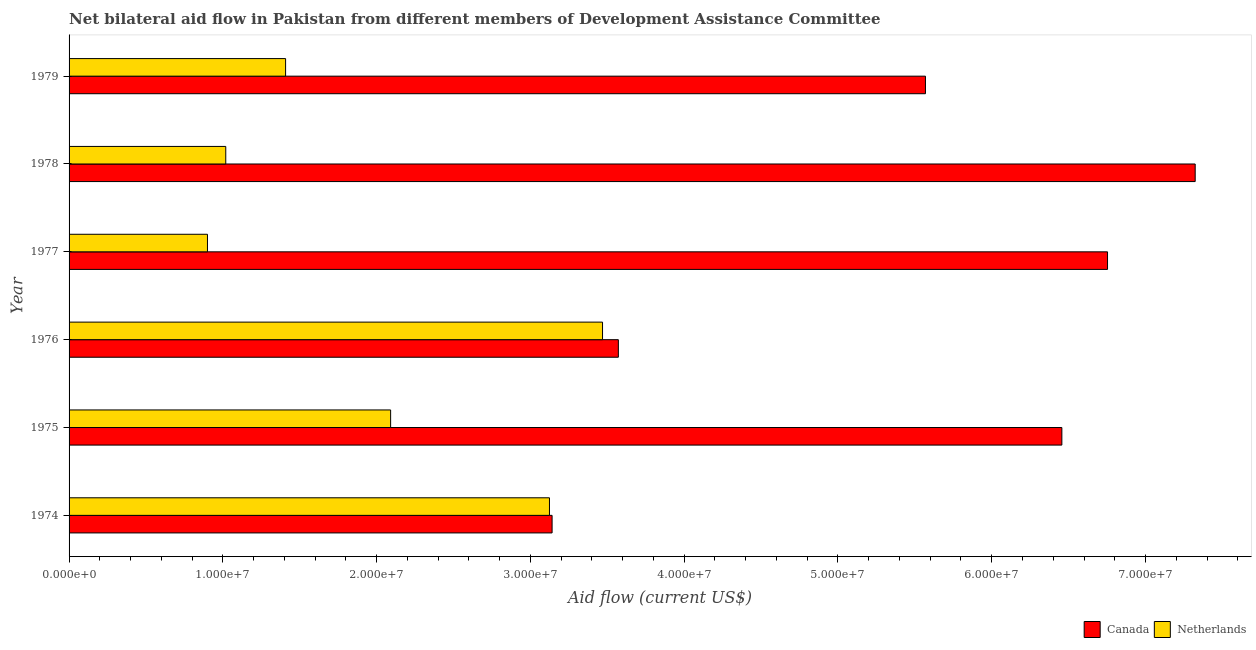How many different coloured bars are there?
Your response must be concise. 2. Are the number of bars on each tick of the Y-axis equal?
Your answer should be compact. Yes. How many bars are there on the 6th tick from the top?
Provide a succinct answer. 2. What is the label of the 2nd group of bars from the top?
Keep it short and to the point. 1978. What is the amount of aid given by netherlands in 1976?
Keep it short and to the point. 3.47e+07. Across all years, what is the maximum amount of aid given by canada?
Your answer should be compact. 7.32e+07. Across all years, what is the minimum amount of aid given by netherlands?
Keep it short and to the point. 9.00e+06. In which year was the amount of aid given by netherlands maximum?
Your response must be concise. 1976. In which year was the amount of aid given by canada minimum?
Ensure brevity in your answer.  1974. What is the total amount of aid given by netherlands in the graph?
Offer a very short reply. 1.20e+08. What is the difference between the amount of aid given by canada in 1975 and that in 1978?
Give a very brief answer. -8.67e+06. What is the difference between the amount of aid given by canada in 1975 and the amount of aid given by netherlands in 1976?
Offer a very short reply. 2.99e+07. What is the average amount of aid given by netherlands per year?
Offer a very short reply. 2.00e+07. In the year 1978, what is the difference between the amount of aid given by canada and amount of aid given by netherlands?
Your answer should be compact. 6.30e+07. What is the ratio of the amount of aid given by canada in 1976 to that in 1978?
Keep it short and to the point. 0.49. What is the difference between the highest and the second highest amount of aid given by netherlands?
Provide a succinct answer. 3.45e+06. What is the difference between the highest and the lowest amount of aid given by netherlands?
Offer a very short reply. 2.57e+07. Is the sum of the amount of aid given by canada in 1976 and 1978 greater than the maximum amount of aid given by netherlands across all years?
Your answer should be compact. Yes. What does the 1st bar from the bottom in 1977 represents?
Provide a succinct answer. Canada. How many years are there in the graph?
Offer a very short reply. 6. What is the difference between two consecutive major ticks on the X-axis?
Ensure brevity in your answer.  1.00e+07. Does the graph contain any zero values?
Your answer should be compact. No. Where does the legend appear in the graph?
Provide a short and direct response. Bottom right. How are the legend labels stacked?
Your answer should be very brief. Horizontal. What is the title of the graph?
Your answer should be very brief. Net bilateral aid flow in Pakistan from different members of Development Assistance Committee. Does "Health Care" appear as one of the legend labels in the graph?
Offer a terse response. No. What is the label or title of the X-axis?
Keep it short and to the point. Aid flow (current US$). What is the Aid flow (current US$) in Canada in 1974?
Provide a succinct answer. 3.14e+07. What is the Aid flow (current US$) of Netherlands in 1974?
Provide a short and direct response. 3.12e+07. What is the Aid flow (current US$) in Canada in 1975?
Ensure brevity in your answer.  6.46e+07. What is the Aid flow (current US$) of Netherlands in 1975?
Keep it short and to the point. 2.09e+07. What is the Aid flow (current US$) in Canada in 1976?
Provide a succinct answer. 3.57e+07. What is the Aid flow (current US$) of Netherlands in 1976?
Provide a short and direct response. 3.47e+07. What is the Aid flow (current US$) of Canada in 1977?
Your answer should be compact. 6.75e+07. What is the Aid flow (current US$) of Netherlands in 1977?
Provide a short and direct response. 9.00e+06. What is the Aid flow (current US$) in Canada in 1978?
Make the answer very short. 7.32e+07. What is the Aid flow (current US$) of Netherlands in 1978?
Make the answer very short. 1.02e+07. What is the Aid flow (current US$) of Canada in 1979?
Provide a short and direct response. 5.57e+07. What is the Aid flow (current US$) of Netherlands in 1979?
Offer a very short reply. 1.41e+07. Across all years, what is the maximum Aid flow (current US$) of Canada?
Offer a very short reply. 7.32e+07. Across all years, what is the maximum Aid flow (current US$) of Netherlands?
Your response must be concise. 3.47e+07. Across all years, what is the minimum Aid flow (current US$) in Canada?
Make the answer very short. 3.14e+07. Across all years, what is the minimum Aid flow (current US$) of Netherlands?
Offer a terse response. 9.00e+06. What is the total Aid flow (current US$) in Canada in the graph?
Keep it short and to the point. 3.28e+08. What is the total Aid flow (current US$) in Netherlands in the graph?
Offer a very short reply. 1.20e+08. What is the difference between the Aid flow (current US$) in Canada in 1974 and that in 1975?
Offer a very short reply. -3.32e+07. What is the difference between the Aid flow (current US$) in Netherlands in 1974 and that in 1975?
Provide a short and direct response. 1.03e+07. What is the difference between the Aid flow (current US$) in Canada in 1974 and that in 1976?
Keep it short and to the point. -4.31e+06. What is the difference between the Aid flow (current US$) in Netherlands in 1974 and that in 1976?
Provide a short and direct response. -3.45e+06. What is the difference between the Aid flow (current US$) of Canada in 1974 and that in 1977?
Provide a short and direct response. -3.61e+07. What is the difference between the Aid flow (current US$) of Netherlands in 1974 and that in 1977?
Offer a very short reply. 2.22e+07. What is the difference between the Aid flow (current US$) of Canada in 1974 and that in 1978?
Provide a succinct answer. -4.18e+07. What is the difference between the Aid flow (current US$) in Netherlands in 1974 and that in 1978?
Make the answer very short. 2.10e+07. What is the difference between the Aid flow (current US$) of Canada in 1974 and that in 1979?
Offer a very short reply. -2.43e+07. What is the difference between the Aid flow (current US$) in Netherlands in 1974 and that in 1979?
Ensure brevity in your answer.  1.72e+07. What is the difference between the Aid flow (current US$) of Canada in 1975 and that in 1976?
Ensure brevity in your answer.  2.88e+07. What is the difference between the Aid flow (current US$) in Netherlands in 1975 and that in 1976?
Your answer should be very brief. -1.38e+07. What is the difference between the Aid flow (current US$) of Canada in 1975 and that in 1977?
Offer a terse response. -2.97e+06. What is the difference between the Aid flow (current US$) in Netherlands in 1975 and that in 1977?
Make the answer very short. 1.19e+07. What is the difference between the Aid flow (current US$) in Canada in 1975 and that in 1978?
Give a very brief answer. -8.67e+06. What is the difference between the Aid flow (current US$) of Netherlands in 1975 and that in 1978?
Offer a terse response. 1.07e+07. What is the difference between the Aid flow (current US$) of Canada in 1975 and that in 1979?
Provide a succinct answer. 8.87e+06. What is the difference between the Aid flow (current US$) of Netherlands in 1975 and that in 1979?
Give a very brief answer. 6.83e+06. What is the difference between the Aid flow (current US$) in Canada in 1976 and that in 1977?
Make the answer very short. -3.18e+07. What is the difference between the Aid flow (current US$) of Netherlands in 1976 and that in 1977?
Provide a succinct answer. 2.57e+07. What is the difference between the Aid flow (current US$) in Canada in 1976 and that in 1978?
Make the answer very short. -3.75e+07. What is the difference between the Aid flow (current US$) of Netherlands in 1976 and that in 1978?
Your answer should be very brief. 2.45e+07. What is the difference between the Aid flow (current US$) in Canada in 1976 and that in 1979?
Give a very brief answer. -2.00e+07. What is the difference between the Aid flow (current US$) in Netherlands in 1976 and that in 1979?
Provide a succinct answer. 2.06e+07. What is the difference between the Aid flow (current US$) of Canada in 1977 and that in 1978?
Your response must be concise. -5.70e+06. What is the difference between the Aid flow (current US$) in Netherlands in 1977 and that in 1978?
Make the answer very short. -1.19e+06. What is the difference between the Aid flow (current US$) in Canada in 1977 and that in 1979?
Offer a terse response. 1.18e+07. What is the difference between the Aid flow (current US$) in Netherlands in 1977 and that in 1979?
Provide a succinct answer. -5.08e+06. What is the difference between the Aid flow (current US$) in Canada in 1978 and that in 1979?
Keep it short and to the point. 1.75e+07. What is the difference between the Aid flow (current US$) of Netherlands in 1978 and that in 1979?
Your answer should be compact. -3.89e+06. What is the difference between the Aid flow (current US$) of Canada in 1974 and the Aid flow (current US$) of Netherlands in 1975?
Make the answer very short. 1.05e+07. What is the difference between the Aid flow (current US$) in Canada in 1974 and the Aid flow (current US$) in Netherlands in 1976?
Provide a succinct answer. -3.28e+06. What is the difference between the Aid flow (current US$) of Canada in 1974 and the Aid flow (current US$) of Netherlands in 1977?
Provide a short and direct response. 2.24e+07. What is the difference between the Aid flow (current US$) in Canada in 1974 and the Aid flow (current US$) in Netherlands in 1978?
Your answer should be very brief. 2.12e+07. What is the difference between the Aid flow (current US$) in Canada in 1974 and the Aid flow (current US$) in Netherlands in 1979?
Offer a terse response. 1.73e+07. What is the difference between the Aid flow (current US$) of Canada in 1975 and the Aid flow (current US$) of Netherlands in 1976?
Your response must be concise. 2.99e+07. What is the difference between the Aid flow (current US$) of Canada in 1975 and the Aid flow (current US$) of Netherlands in 1977?
Offer a very short reply. 5.56e+07. What is the difference between the Aid flow (current US$) in Canada in 1975 and the Aid flow (current US$) in Netherlands in 1978?
Provide a succinct answer. 5.44e+07. What is the difference between the Aid flow (current US$) in Canada in 1975 and the Aid flow (current US$) in Netherlands in 1979?
Provide a short and direct response. 5.05e+07. What is the difference between the Aid flow (current US$) of Canada in 1976 and the Aid flow (current US$) of Netherlands in 1977?
Your answer should be very brief. 2.67e+07. What is the difference between the Aid flow (current US$) of Canada in 1976 and the Aid flow (current US$) of Netherlands in 1978?
Provide a succinct answer. 2.55e+07. What is the difference between the Aid flow (current US$) of Canada in 1976 and the Aid flow (current US$) of Netherlands in 1979?
Your answer should be very brief. 2.16e+07. What is the difference between the Aid flow (current US$) in Canada in 1977 and the Aid flow (current US$) in Netherlands in 1978?
Offer a terse response. 5.73e+07. What is the difference between the Aid flow (current US$) of Canada in 1977 and the Aid flow (current US$) of Netherlands in 1979?
Keep it short and to the point. 5.34e+07. What is the difference between the Aid flow (current US$) in Canada in 1978 and the Aid flow (current US$) in Netherlands in 1979?
Offer a terse response. 5.92e+07. What is the average Aid flow (current US$) of Canada per year?
Provide a succinct answer. 5.47e+07. What is the average Aid flow (current US$) in Netherlands per year?
Give a very brief answer. 2.00e+07. In the year 1975, what is the difference between the Aid flow (current US$) in Canada and Aid flow (current US$) in Netherlands?
Offer a very short reply. 4.36e+07. In the year 1976, what is the difference between the Aid flow (current US$) in Canada and Aid flow (current US$) in Netherlands?
Keep it short and to the point. 1.03e+06. In the year 1977, what is the difference between the Aid flow (current US$) in Canada and Aid flow (current US$) in Netherlands?
Your answer should be very brief. 5.85e+07. In the year 1978, what is the difference between the Aid flow (current US$) in Canada and Aid flow (current US$) in Netherlands?
Offer a terse response. 6.30e+07. In the year 1979, what is the difference between the Aid flow (current US$) of Canada and Aid flow (current US$) of Netherlands?
Ensure brevity in your answer.  4.16e+07. What is the ratio of the Aid flow (current US$) of Canada in 1974 to that in 1975?
Your answer should be very brief. 0.49. What is the ratio of the Aid flow (current US$) of Netherlands in 1974 to that in 1975?
Your response must be concise. 1.49. What is the ratio of the Aid flow (current US$) of Canada in 1974 to that in 1976?
Your answer should be compact. 0.88. What is the ratio of the Aid flow (current US$) of Netherlands in 1974 to that in 1976?
Give a very brief answer. 0.9. What is the ratio of the Aid flow (current US$) of Canada in 1974 to that in 1977?
Offer a terse response. 0.47. What is the ratio of the Aid flow (current US$) in Netherlands in 1974 to that in 1977?
Offer a terse response. 3.47. What is the ratio of the Aid flow (current US$) of Canada in 1974 to that in 1978?
Make the answer very short. 0.43. What is the ratio of the Aid flow (current US$) in Netherlands in 1974 to that in 1978?
Provide a succinct answer. 3.07. What is the ratio of the Aid flow (current US$) in Canada in 1974 to that in 1979?
Give a very brief answer. 0.56. What is the ratio of the Aid flow (current US$) of Netherlands in 1974 to that in 1979?
Provide a succinct answer. 2.22. What is the ratio of the Aid flow (current US$) of Canada in 1975 to that in 1976?
Offer a very short reply. 1.81. What is the ratio of the Aid flow (current US$) of Netherlands in 1975 to that in 1976?
Offer a very short reply. 0.6. What is the ratio of the Aid flow (current US$) of Canada in 1975 to that in 1977?
Give a very brief answer. 0.96. What is the ratio of the Aid flow (current US$) in Netherlands in 1975 to that in 1977?
Make the answer very short. 2.32. What is the ratio of the Aid flow (current US$) of Canada in 1975 to that in 1978?
Offer a terse response. 0.88. What is the ratio of the Aid flow (current US$) of Netherlands in 1975 to that in 1978?
Keep it short and to the point. 2.05. What is the ratio of the Aid flow (current US$) of Canada in 1975 to that in 1979?
Give a very brief answer. 1.16. What is the ratio of the Aid flow (current US$) of Netherlands in 1975 to that in 1979?
Give a very brief answer. 1.49. What is the ratio of the Aid flow (current US$) of Canada in 1976 to that in 1977?
Offer a terse response. 0.53. What is the ratio of the Aid flow (current US$) in Netherlands in 1976 to that in 1977?
Offer a very short reply. 3.85. What is the ratio of the Aid flow (current US$) of Canada in 1976 to that in 1978?
Your response must be concise. 0.49. What is the ratio of the Aid flow (current US$) in Netherlands in 1976 to that in 1978?
Ensure brevity in your answer.  3.4. What is the ratio of the Aid flow (current US$) of Canada in 1976 to that in 1979?
Make the answer very short. 0.64. What is the ratio of the Aid flow (current US$) of Netherlands in 1976 to that in 1979?
Offer a terse response. 2.46. What is the ratio of the Aid flow (current US$) in Canada in 1977 to that in 1978?
Make the answer very short. 0.92. What is the ratio of the Aid flow (current US$) of Netherlands in 1977 to that in 1978?
Ensure brevity in your answer.  0.88. What is the ratio of the Aid flow (current US$) in Canada in 1977 to that in 1979?
Keep it short and to the point. 1.21. What is the ratio of the Aid flow (current US$) in Netherlands in 1977 to that in 1979?
Offer a terse response. 0.64. What is the ratio of the Aid flow (current US$) in Canada in 1978 to that in 1979?
Keep it short and to the point. 1.31. What is the ratio of the Aid flow (current US$) of Netherlands in 1978 to that in 1979?
Provide a short and direct response. 0.72. What is the difference between the highest and the second highest Aid flow (current US$) in Canada?
Your answer should be very brief. 5.70e+06. What is the difference between the highest and the second highest Aid flow (current US$) of Netherlands?
Keep it short and to the point. 3.45e+06. What is the difference between the highest and the lowest Aid flow (current US$) of Canada?
Provide a short and direct response. 4.18e+07. What is the difference between the highest and the lowest Aid flow (current US$) in Netherlands?
Provide a succinct answer. 2.57e+07. 